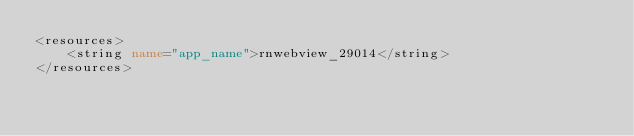Convert code to text. <code><loc_0><loc_0><loc_500><loc_500><_XML_><resources>
    <string name="app_name">rnwebview_29014</string>
</resources>
</code> 